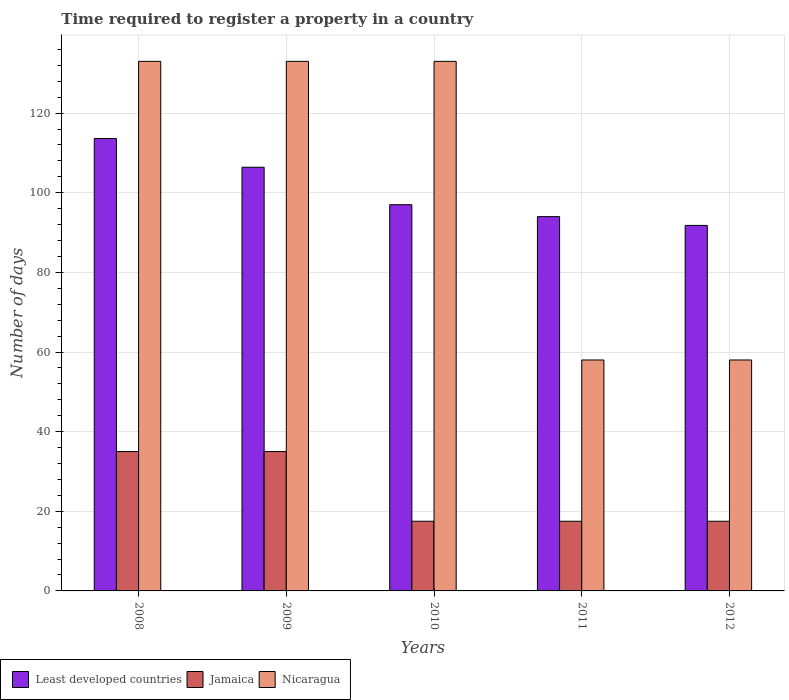How many bars are there on the 5th tick from the left?
Keep it short and to the point. 3. How many bars are there on the 1st tick from the right?
Offer a terse response. 3. What is the label of the 5th group of bars from the left?
Offer a very short reply. 2012. What is the number of days required to register a property in Least developed countries in 2010?
Make the answer very short. 97. Across all years, what is the maximum number of days required to register a property in Jamaica?
Make the answer very short. 35. Across all years, what is the minimum number of days required to register a property in Nicaragua?
Keep it short and to the point. 58. In which year was the number of days required to register a property in Jamaica maximum?
Provide a short and direct response. 2008. What is the total number of days required to register a property in Least developed countries in the graph?
Keep it short and to the point. 502.82. What is the difference between the number of days required to register a property in Nicaragua in 2008 and that in 2009?
Your response must be concise. 0. What is the difference between the number of days required to register a property in Least developed countries in 2011 and the number of days required to register a property in Nicaragua in 2009?
Provide a short and direct response. -39. What is the average number of days required to register a property in Nicaragua per year?
Offer a terse response. 103. In the year 2011, what is the difference between the number of days required to register a property in Nicaragua and number of days required to register a property in Least developed countries?
Offer a terse response. -36. What is the ratio of the number of days required to register a property in Nicaragua in 2008 to that in 2012?
Keep it short and to the point. 2.29. Is the number of days required to register a property in Jamaica in 2008 less than that in 2010?
Your answer should be compact. No. What is the difference between the highest and the second highest number of days required to register a property in Least developed countries?
Your response must be concise. 7.21. What is the difference between the highest and the lowest number of days required to register a property in Least developed countries?
Make the answer very short. 21.82. In how many years, is the number of days required to register a property in Jamaica greater than the average number of days required to register a property in Jamaica taken over all years?
Keep it short and to the point. 2. What does the 2nd bar from the left in 2012 represents?
Your response must be concise. Jamaica. What does the 1st bar from the right in 2010 represents?
Offer a very short reply. Nicaragua. How many bars are there?
Your answer should be compact. 15. What is the difference between two consecutive major ticks on the Y-axis?
Ensure brevity in your answer.  20. Are the values on the major ticks of Y-axis written in scientific E-notation?
Your answer should be compact. No. Does the graph contain grids?
Your response must be concise. Yes. What is the title of the graph?
Provide a succinct answer. Time required to register a property in a country. What is the label or title of the X-axis?
Ensure brevity in your answer.  Years. What is the label or title of the Y-axis?
Offer a terse response. Number of days. What is the Number of days in Least developed countries in 2008?
Give a very brief answer. 113.62. What is the Number of days of Nicaragua in 2008?
Offer a very short reply. 133. What is the Number of days of Least developed countries in 2009?
Provide a short and direct response. 106.4. What is the Number of days in Jamaica in 2009?
Your answer should be very brief. 35. What is the Number of days of Nicaragua in 2009?
Give a very brief answer. 133. What is the Number of days of Least developed countries in 2010?
Ensure brevity in your answer.  97. What is the Number of days in Nicaragua in 2010?
Provide a succinct answer. 133. What is the Number of days in Least developed countries in 2011?
Your answer should be very brief. 94. What is the Number of days of Jamaica in 2011?
Give a very brief answer. 17.5. What is the Number of days of Least developed countries in 2012?
Make the answer very short. 91.8. What is the Number of days in Nicaragua in 2012?
Your response must be concise. 58. Across all years, what is the maximum Number of days in Least developed countries?
Offer a terse response. 113.62. Across all years, what is the maximum Number of days of Nicaragua?
Your answer should be very brief. 133. Across all years, what is the minimum Number of days of Least developed countries?
Offer a very short reply. 91.8. What is the total Number of days of Least developed countries in the graph?
Ensure brevity in your answer.  502.82. What is the total Number of days in Jamaica in the graph?
Provide a succinct answer. 122.5. What is the total Number of days in Nicaragua in the graph?
Your answer should be very brief. 515. What is the difference between the Number of days in Least developed countries in 2008 and that in 2009?
Make the answer very short. 7.21. What is the difference between the Number of days of Jamaica in 2008 and that in 2009?
Provide a short and direct response. 0. What is the difference between the Number of days of Least developed countries in 2008 and that in 2010?
Provide a short and direct response. 16.62. What is the difference between the Number of days in Nicaragua in 2008 and that in 2010?
Your response must be concise. 0. What is the difference between the Number of days in Least developed countries in 2008 and that in 2011?
Provide a succinct answer. 19.62. What is the difference between the Number of days in Nicaragua in 2008 and that in 2011?
Your answer should be very brief. 75. What is the difference between the Number of days in Least developed countries in 2008 and that in 2012?
Provide a short and direct response. 21.82. What is the difference between the Number of days of Jamaica in 2008 and that in 2012?
Your answer should be compact. 17.5. What is the difference between the Number of days of Nicaragua in 2008 and that in 2012?
Provide a short and direct response. 75. What is the difference between the Number of days of Least developed countries in 2009 and that in 2010?
Your answer should be very brief. 9.4. What is the difference between the Number of days of Nicaragua in 2009 and that in 2010?
Your answer should be very brief. 0. What is the difference between the Number of days in Least developed countries in 2009 and that in 2011?
Your response must be concise. 12.4. What is the difference between the Number of days of Least developed countries in 2009 and that in 2012?
Offer a terse response. 14.61. What is the difference between the Number of days in Jamaica in 2009 and that in 2012?
Keep it short and to the point. 17.5. What is the difference between the Number of days of Least developed countries in 2010 and that in 2012?
Keep it short and to the point. 5.2. What is the difference between the Number of days of Jamaica in 2010 and that in 2012?
Offer a very short reply. 0. What is the difference between the Number of days in Least developed countries in 2011 and that in 2012?
Your answer should be compact. 2.2. What is the difference between the Number of days of Jamaica in 2011 and that in 2012?
Offer a very short reply. 0. What is the difference between the Number of days in Nicaragua in 2011 and that in 2012?
Your answer should be very brief. 0. What is the difference between the Number of days in Least developed countries in 2008 and the Number of days in Jamaica in 2009?
Provide a short and direct response. 78.62. What is the difference between the Number of days in Least developed countries in 2008 and the Number of days in Nicaragua in 2009?
Give a very brief answer. -19.38. What is the difference between the Number of days of Jamaica in 2008 and the Number of days of Nicaragua in 2009?
Provide a short and direct response. -98. What is the difference between the Number of days of Least developed countries in 2008 and the Number of days of Jamaica in 2010?
Provide a short and direct response. 96.12. What is the difference between the Number of days of Least developed countries in 2008 and the Number of days of Nicaragua in 2010?
Make the answer very short. -19.38. What is the difference between the Number of days in Jamaica in 2008 and the Number of days in Nicaragua in 2010?
Give a very brief answer. -98. What is the difference between the Number of days in Least developed countries in 2008 and the Number of days in Jamaica in 2011?
Your answer should be compact. 96.12. What is the difference between the Number of days in Least developed countries in 2008 and the Number of days in Nicaragua in 2011?
Offer a very short reply. 55.62. What is the difference between the Number of days in Jamaica in 2008 and the Number of days in Nicaragua in 2011?
Ensure brevity in your answer.  -23. What is the difference between the Number of days of Least developed countries in 2008 and the Number of days of Jamaica in 2012?
Provide a succinct answer. 96.12. What is the difference between the Number of days of Least developed countries in 2008 and the Number of days of Nicaragua in 2012?
Provide a short and direct response. 55.62. What is the difference between the Number of days of Least developed countries in 2009 and the Number of days of Jamaica in 2010?
Give a very brief answer. 88.9. What is the difference between the Number of days of Least developed countries in 2009 and the Number of days of Nicaragua in 2010?
Give a very brief answer. -26.6. What is the difference between the Number of days of Jamaica in 2009 and the Number of days of Nicaragua in 2010?
Offer a very short reply. -98. What is the difference between the Number of days of Least developed countries in 2009 and the Number of days of Jamaica in 2011?
Offer a terse response. 88.9. What is the difference between the Number of days in Least developed countries in 2009 and the Number of days in Nicaragua in 2011?
Offer a terse response. 48.4. What is the difference between the Number of days of Least developed countries in 2009 and the Number of days of Jamaica in 2012?
Your answer should be very brief. 88.9. What is the difference between the Number of days of Least developed countries in 2009 and the Number of days of Nicaragua in 2012?
Your response must be concise. 48.4. What is the difference between the Number of days in Least developed countries in 2010 and the Number of days in Jamaica in 2011?
Ensure brevity in your answer.  79.5. What is the difference between the Number of days in Jamaica in 2010 and the Number of days in Nicaragua in 2011?
Provide a succinct answer. -40.5. What is the difference between the Number of days in Least developed countries in 2010 and the Number of days in Jamaica in 2012?
Give a very brief answer. 79.5. What is the difference between the Number of days of Least developed countries in 2010 and the Number of days of Nicaragua in 2012?
Keep it short and to the point. 39. What is the difference between the Number of days in Jamaica in 2010 and the Number of days in Nicaragua in 2012?
Keep it short and to the point. -40.5. What is the difference between the Number of days of Least developed countries in 2011 and the Number of days of Jamaica in 2012?
Offer a terse response. 76.5. What is the difference between the Number of days of Jamaica in 2011 and the Number of days of Nicaragua in 2012?
Provide a short and direct response. -40.5. What is the average Number of days in Least developed countries per year?
Give a very brief answer. 100.56. What is the average Number of days in Nicaragua per year?
Make the answer very short. 103. In the year 2008, what is the difference between the Number of days in Least developed countries and Number of days in Jamaica?
Offer a terse response. 78.62. In the year 2008, what is the difference between the Number of days in Least developed countries and Number of days in Nicaragua?
Give a very brief answer. -19.38. In the year 2008, what is the difference between the Number of days in Jamaica and Number of days in Nicaragua?
Provide a short and direct response. -98. In the year 2009, what is the difference between the Number of days in Least developed countries and Number of days in Jamaica?
Your response must be concise. 71.4. In the year 2009, what is the difference between the Number of days of Least developed countries and Number of days of Nicaragua?
Your answer should be compact. -26.6. In the year 2009, what is the difference between the Number of days in Jamaica and Number of days in Nicaragua?
Offer a terse response. -98. In the year 2010, what is the difference between the Number of days of Least developed countries and Number of days of Jamaica?
Provide a short and direct response. 79.5. In the year 2010, what is the difference between the Number of days in Least developed countries and Number of days in Nicaragua?
Provide a succinct answer. -36. In the year 2010, what is the difference between the Number of days of Jamaica and Number of days of Nicaragua?
Make the answer very short. -115.5. In the year 2011, what is the difference between the Number of days in Least developed countries and Number of days in Jamaica?
Provide a succinct answer. 76.5. In the year 2011, what is the difference between the Number of days in Jamaica and Number of days in Nicaragua?
Give a very brief answer. -40.5. In the year 2012, what is the difference between the Number of days of Least developed countries and Number of days of Jamaica?
Make the answer very short. 74.3. In the year 2012, what is the difference between the Number of days of Least developed countries and Number of days of Nicaragua?
Provide a succinct answer. 33.8. In the year 2012, what is the difference between the Number of days in Jamaica and Number of days in Nicaragua?
Ensure brevity in your answer.  -40.5. What is the ratio of the Number of days of Least developed countries in 2008 to that in 2009?
Give a very brief answer. 1.07. What is the ratio of the Number of days of Least developed countries in 2008 to that in 2010?
Your answer should be compact. 1.17. What is the ratio of the Number of days of Nicaragua in 2008 to that in 2010?
Keep it short and to the point. 1. What is the ratio of the Number of days of Least developed countries in 2008 to that in 2011?
Keep it short and to the point. 1.21. What is the ratio of the Number of days of Jamaica in 2008 to that in 2011?
Keep it short and to the point. 2. What is the ratio of the Number of days in Nicaragua in 2008 to that in 2011?
Your answer should be very brief. 2.29. What is the ratio of the Number of days in Least developed countries in 2008 to that in 2012?
Ensure brevity in your answer.  1.24. What is the ratio of the Number of days in Nicaragua in 2008 to that in 2012?
Provide a succinct answer. 2.29. What is the ratio of the Number of days of Least developed countries in 2009 to that in 2010?
Your response must be concise. 1.1. What is the ratio of the Number of days in Nicaragua in 2009 to that in 2010?
Give a very brief answer. 1. What is the ratio of the Number of days of Least developed countries in 2009 to that in 2011?
Offer a very short reply. 1.13. What is the ratio of the Number of days of Jamaica in 2009 to that in 2011?
Provide a succinct answer. 2. What is the ratio of the Number of days of Nicaragua in 2009 to that in 2011?
Keep it short and to the point. 2.29. What is the ratio of the Number of days of Least developed countries in 2009 to that in 2012?
Your answer should be very brief. 1.16. What is the ratio of the Number of days in Nicaragua in 2009 to that in 2012?
Offer a very short reply. 2.29. What is the ratio of the Number of days of Least developed countries in 2010 to that in 2011?
Your response must be concise. 1.03. What is the ratio of the Number of days of Nicaragua in 2010 to that in 2011?
Offer a very short reply. 2.29. What is the ratio of the Number of days of Least developed countries in 2010 to that in 2012?
Your response must be concise. 1.06. What is the ratio of the Number of days of Nicaragua in 2010 to that in 2012?
Offer a terse response. 2.29. What is the ratio of the Number of days in Jamaica in 2011 to that in 2012?
Your answer should be compact. 1. What is the difference between the highest and the second highest Number of days of Least developed countries?
Offer a terse response. 7.21. What is the difference between the highest and the second highest Number of days in Nicaragua?
Provide a succinct answer. 0. What is the difference between the highest and the lowest Number of days in Least developed countries?
Keep it short and to the point. 21.82. 